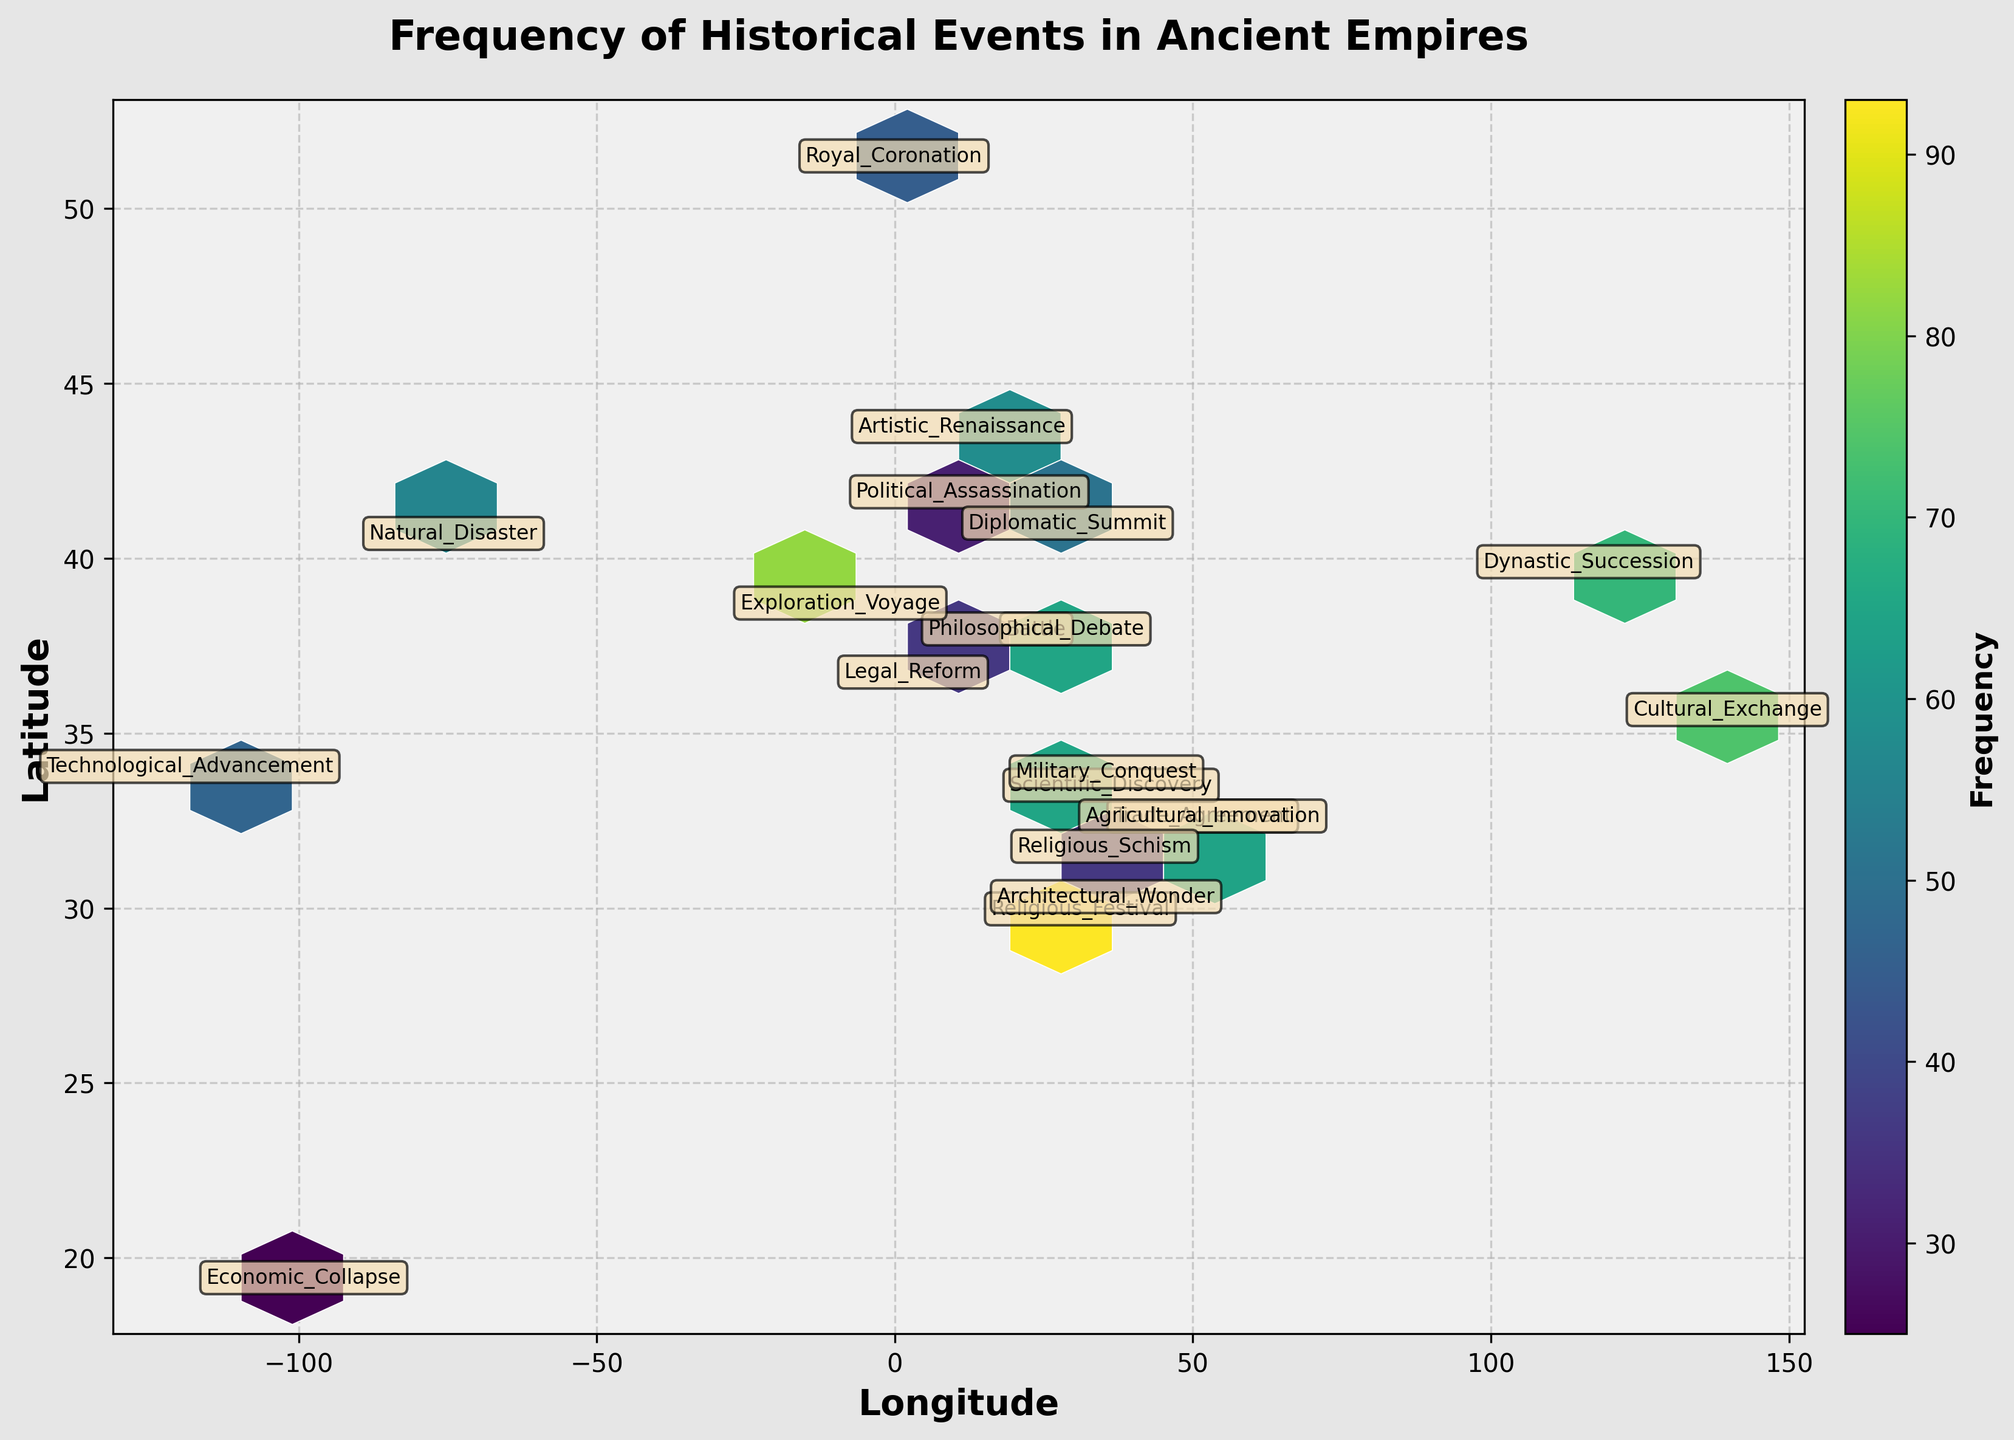How many events are displayed in the plot? To find the number of events displayed in the plot, look for the annotations or the number of different labeled points on the figure. By counting these annotations, you will know the total number of events displayed.
Answer: 20 What is the title of the figure? The title of the figure is usually placed at the top center of the plot in a large, bold font. It summarizes what the figure is about.
Answer: Frequency of Historical Events in Ancient Empires Which axis represents latitude and which represents longitude? The axes are labeled along the x and y axes. The label along the bottom (horizontal) axis represents longitude, and the label along the left side (vertical) axis represents latitude.
Answer: Latitude is on the y-axis, and Longitude is on the x-axis What is the most frequent type of event and where is it located? By identifying the annotated points and checking the color intensity on the hexbin plot corresponding to the highest value on the color scale, you can determine the most frequent event and its geographical location in terms of latitude and longitude. The highest frequency is indicated by the most intense color.
Answer: Military_Conquest in 33.8938, 35.5018 Which event is annotated near the coordinates (29.9792, 31.1342)? Check the point annotated closest to these coordinates. The event type annotated near the latitude of 29.9792 and longitude of 31.1342 will provide the answer.
Answer: Religious_Festival What is the frequency of the Battle event and its location? Locate the annotation labeled "Battle" and observe its vertical and horizontal coordinates. Additionally, check the color associated with this annotation to confirm its frequency by matching it with the color scale bar.
Answer: Frequency: 87, Location: 37.9838, 23.7275 Are there more events located east or west of the prime meridian (longitude 0)? To determine this, observe the number of event annotations on either side of the prime meridian (longitude 0). Count the events on the eastern side (positive longitude) and compare them to the events on the western side (negative longitude).
Answer: East of the prime meridian How many events have frequencies above 50? By examining the annotations and the associated frequency values or color intensities, count the number of events that have frequencies greater than 50.
Answer: 11 Which event is closest to the equator (latitude 0)? To find the event closest to the equator, look for the annotation that has the smallest absolute value for the latitude coordinate. Compare the latitudes of each annotated point.
Answer: Natural_Disaster What is the average frequency of events located between latitudes 30 and 40? Identify the events within the specified latitude range of 30 to 40. Then, sum their frequencies and divide by the number of events in this range to compute the average.
Answer: Average: 70 